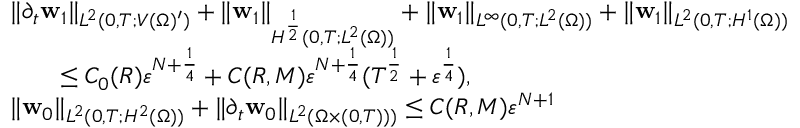<formula> <loc_0><loc_0><loc_500><loc_500>\begin{array} { r l } & { \| \partial _ { t } w _ { 1 } \| _ { L ^ { 2 } ( 0 , T ; V ( \Omega ) ^ { \prime } ) } + \| w _ { 1 } \| _ { H ^ { \frac { 1 } { 2 } } ( 0 , T ; L ^ { 2 } ( \Omega ) ) } + \| w _ { 1 } \| _ { L ^ { \infty } ( 0 , T ; L ^ { 2 } ( \Omega ) ) } + \| w _ { 1 } \| _ { L ^ { 2 } ( 0 , T ; H ^ { 1 } ( \Omega ) ) } } \\ & { \quad \leq C _ { 0 } ( R ) { \varepsilon } ^ { N + \frac { 1 } { 4 } } + C ( R , M ) { \varepsilon } ^ { N + \frac { 1 } { 4 } } ( T ^ { \frac { 1 } { 2 } } + { \varepsilon } ^ { \frac { 1 } { 4 } } ) , } \\ & { \| w _ { 0 } \| _ { L ^ { 2 } ( 0 , T ; H ^ { 2 } ( \Omega ) ) } + \| \partial _ { t } w _ { 0 } \| _ { L ^ { 2 } ( \Omega \times ( 0 , T ) ) ) } \leq C ( R , M ) { \varepsilon } ^ { N + 1 } } \end{array}</formula> 